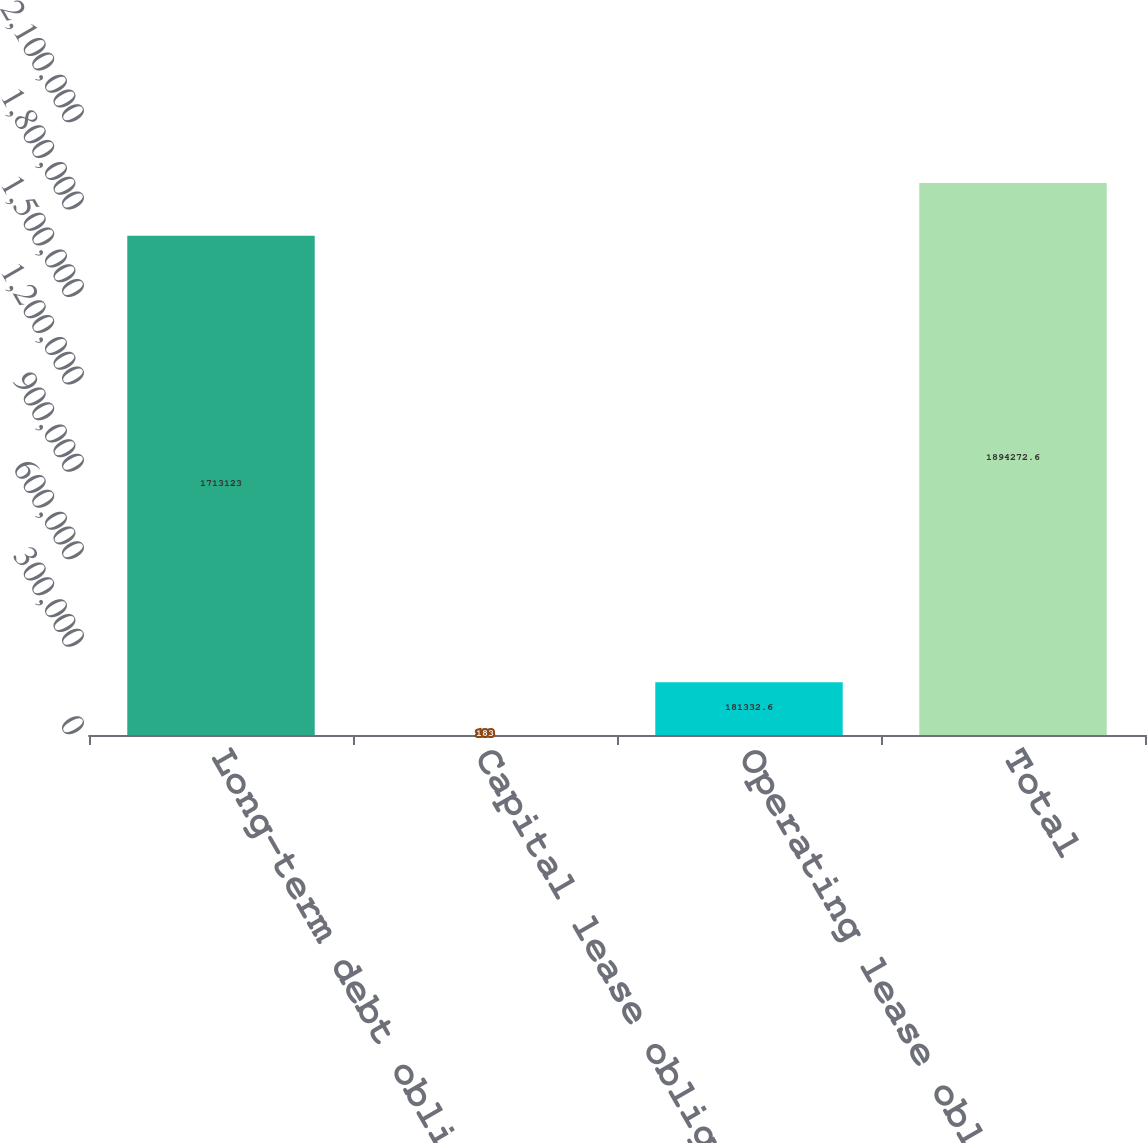Convert chart. <chart><loc_0><loc_0><loc_500><loc_500><bar_chart><fcel>Long-term debt obligations<fcel>Capital lease obligations<fcel>Operating lease obligations<fcel>Total<nl><fcel>1.71312e+06<fcel>183<fcel>181333<fcel>1.89427e+06<nl></chart> 